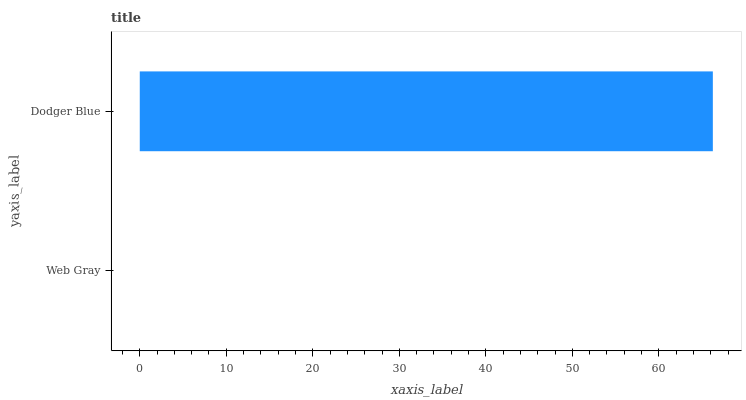Is Web Gray the minimum?
Answer yes or no. Yes. Is Dodger Blue the maximum?
Answer yes or no. Yes. Is Dodger Blue the minimum?
Answer yes or no. No. Is Dodger Blue greater than Web Gray?
Answer yes or no. Yes. Is Web Gray less than Dodger Blue?
Answer yes or no. Yes. Is Web Gray greater than Dodger Blue?
Answer yes or no. No. Is Dodger Blue less than Web Gray?
Answer yes or no. No. Is Dodger Blue the high median?
Answer yes or no. Yes. Is Web Gray the low median?
Answer yes or no. Yes. Is Web Gray the high median?
Answer yes or no. No. Is Dodger Blue the low median?
Answer yes or no. No. 